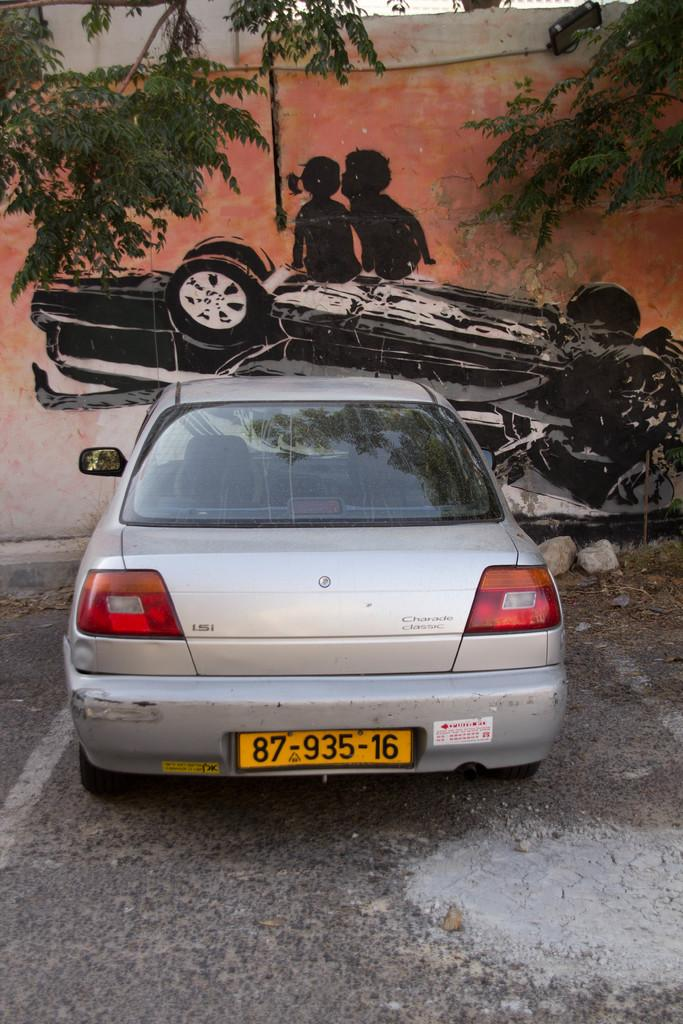<image>
Give a short and clear explanation of the subsequent image. The license plate number for this car is "87-935-16." 